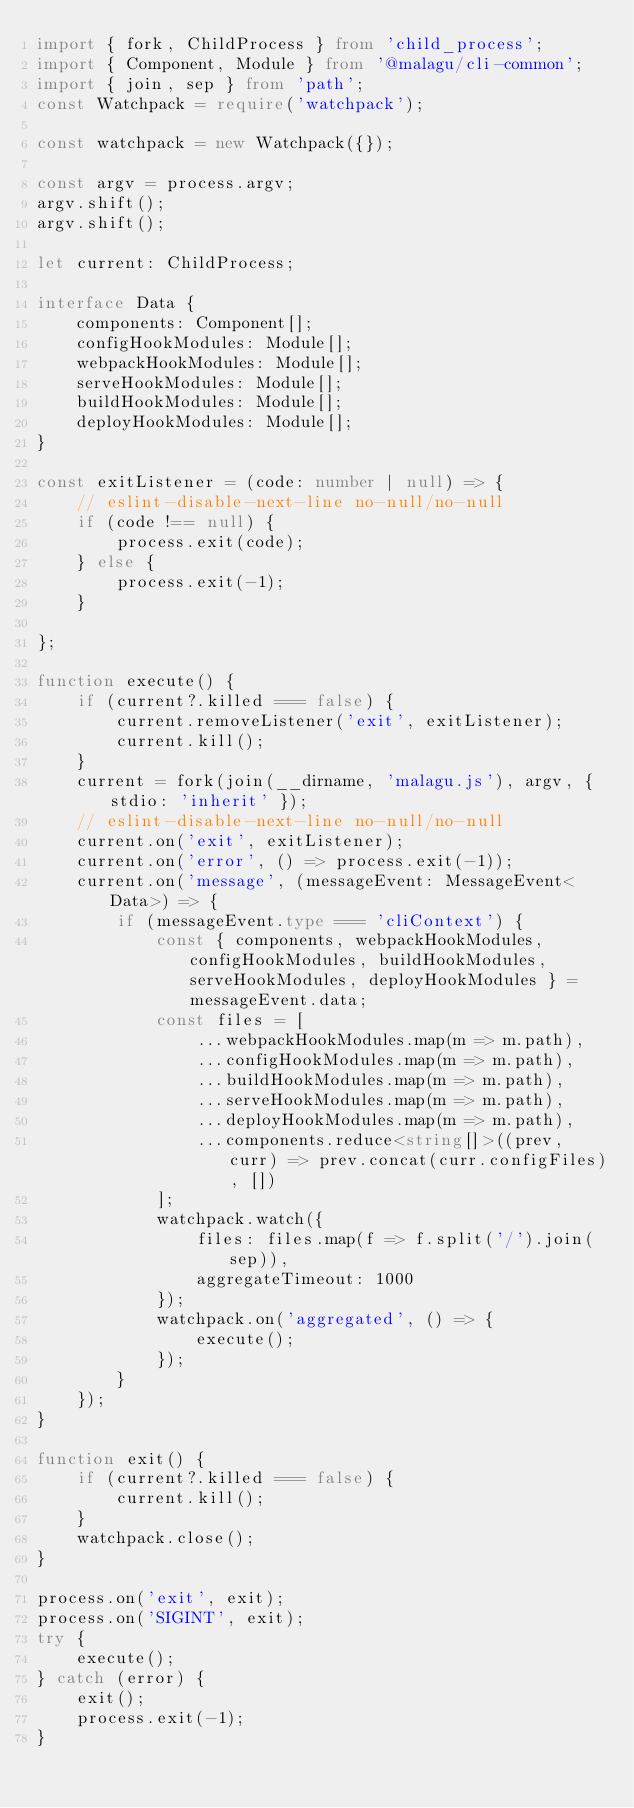Convert code to text. <code><loc_0><loc_0><loc_500><loc_500><_TypeScript_>import { fork, ChildProcess } from 'child_process';
import { Component, Module } from '@malagu/cli-common';
import { join, sep } from 'path';
const Watchpack = require('watchpack');

const watchpack = new Watchpack({});

const argv = process.argv;
argv.shift();
argv.shift();

let current: ChildProcess;

interface Data {
    components: Component[];
    configHookModules: Module[];
    webpackHookModules: Module[];
    serveHookModules: Module[];
    buildHookModules: Module[];
    deployHookModules: Module[];
}

const exitListener = (code: number | null) => {
    // eslint-disable-next-line no-null/no-null
    if (code !== null) {
        process.exit(code);
    } else {
        process.exit(-1);
    }

};

function execute() {
    if (current?.killed === false) {
        current.removeListener('exit', exitListener);
        current.kill();
    }
    current = fork(join(__dirname, 'malagu.js'), argv, { stdio: 'inherit' });
    // eslint-disable-next-line no-null/no-null
    current.on('exit', exitListener);
    current.on('error', () => process.exit(-1));
    current.on('message', (messageEvent: MessageEvent<Data>) => {
        if (messageEvent.type === 'cliContext') {
            const { components, webpackHookModules, configHookModules, buildHookModules, serveHookModules, deployHookModules } = messageEvent.data;
            const files = [
                ...webpackHookModules.map(m => m.path),
                ...configHookModules.map(m => m.path),
                ...buildHookModules.map(m => m.path),
                ...serveHookModules.map(m => m.path),
                ...deployHookModules.map(m => m.path),
                ...components.reduce<string[]>((prev, curr) => prev.concat(curr.configFiles), [])
            ];
            watchpack.watch({
                files: files.map(f => f.split('/').join(sep)),
                aggregateTimeout: 1000
            });
            watchpack.on('aggregated', () => {
                execute();
            });
        }
    });
}

function exit() {
    if (current?.killed === false) {
        current.kill();
    }
    watchpack.close();
}

process.on('exit', exit);
process.on('SIGINT', exit);
try {
    execute();
} catch (error) {
    exit();
    process.exit(-1);
}
</code> 